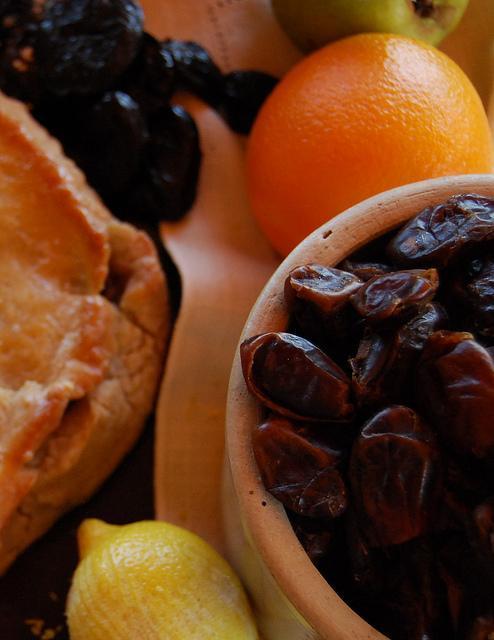How many skateboards are pictured off the ground?
Give a very brief answer. 0. 